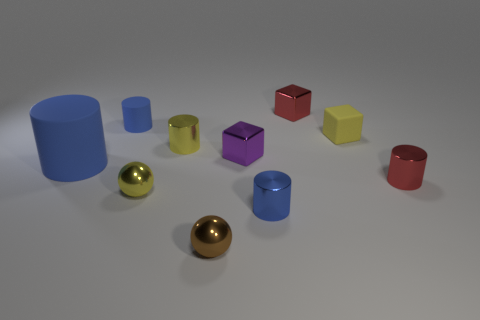Do the red block and the blue cylinder behind the big matte object have the same material?
Ensure brevity in your answer.  No. Are there fewer red objects that are in front of the large blue cylinder than small yellow balls?
Your response must be concise. No. How many other objects are there of the same shape as the blue metal thing?
Offer a very short reply. 4. Are there any other things that have the same color as the matte block?
Provide a succinct answer. Yes. Is the color of the matte cube the same as the cylinder that is behind the yellow cylinder?
Give a very brief answer. No. How many other things are there of the same size as the yellow matte cube?
Keep it short and to the point. 8. There is a metal sphere that is the same color as the matte cube; what is its size?
Your response must be concise. Small. What number of cylinders are either small matte objects or big blue matte things?
Provide a succinct answer. 2. Is the shape of the red shiny object that is in front of the big blue cylinder the same as  the small brown metal object?
Keep it short and to the point. No. Is the number of yellow shiny things that are to the left of the tiny blue rubber cylinder greater than the number of small purple objects?
Your response must be concise. No. 